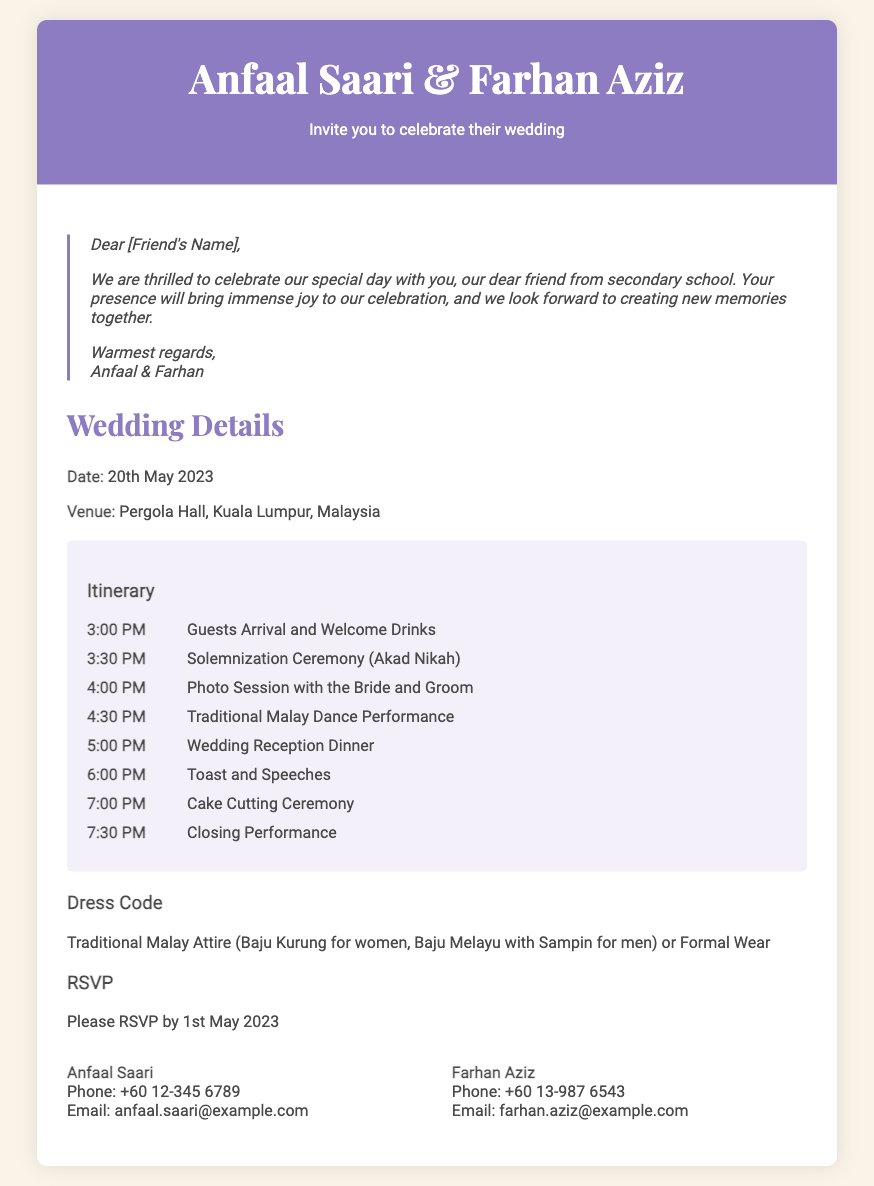what is the date of the wedding? The date of the wedding is specifically mentioned in the document as 20th May 2023.
Answer: 20th May 2023 where is the wedding venue located? The venue for the wedding is stated to be Pergola Hall, Kuala Lumpur, Malaysia.
Answer: Pergola Hall, Kuala Lumpur, Malaysia what time does the wedding reception dinner start? The schedule indicates that the wedding reception dinner begins at 5:00 PM.
Answer: 5:00 PM what is the dress code for the wedding? The dress code requirements specifically mentioned in the document include Traditional Malay Attire or Formal Wear.
Answer: Traditional Malay Attire (Baju Kurung for women, Baju Melayu with Sampin for men) or Formal Wear who should RSVP for the wedding? The personalized note implies that the invitee, referred to as [Friend's Name], is among those who should RSVP.
Answer: [Friend's Name] how should guests contact Anfaal for RSVP? The document provides Anfaal's contact details, including her phone number and email address for RSVP communication.
Answer: Phone: +60 12-345 6789, Email: anfaal.saari@example.com what is the first item on the wedding itinerary? According to the itinerary in the document, the first item listed is Guests Arrival and Welcome Drinks.
Answer: Guests Arrival and Welcome Drinks how many items are listed in the itinerary? The itinerary includes a total of 8 events or items scheduled throughout the wedding ceremony.
Answer: 8 items what is the theme of the wedding invitation? The overall theme reflected in the document suggests an Elegant Traditional Malay style for the wedding invitation.
Answer: Elegant Traditional Malay 